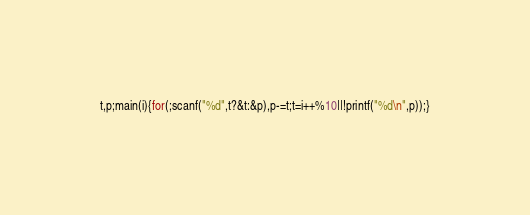Convert code to text. <code><loc_0><loc_0><loc_500><loc_500><_C_>t,p;main(i){for(;scanf("%d",t?&t:&p),p-=t;t=i++%10||!printf("%d\n",p));}</code> 